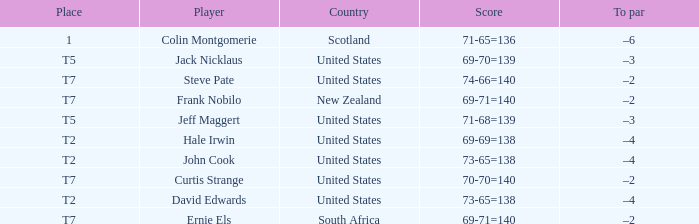What is the name of the golfer that has the score of 73-65=138? John Cook, David Edwards. 